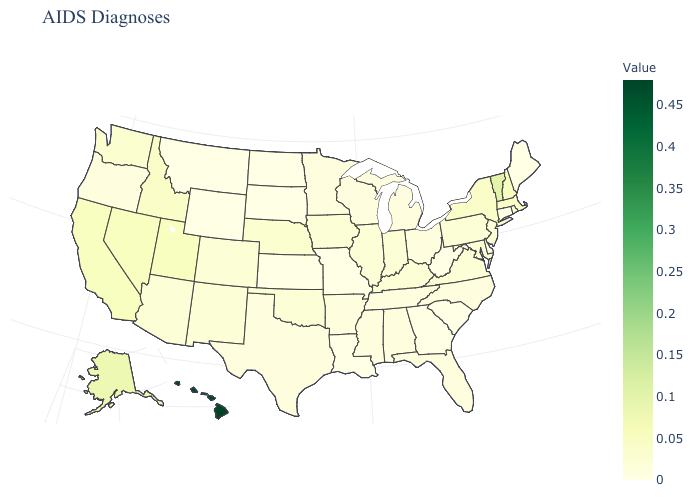Which states have the lowest value in the South?
Concise answer only. Delaware, Georgia, Louisiana, South Carolina, West Virginia. Does South Dakota have the highest value in the MidWest?
Give a very brief answer. No. 